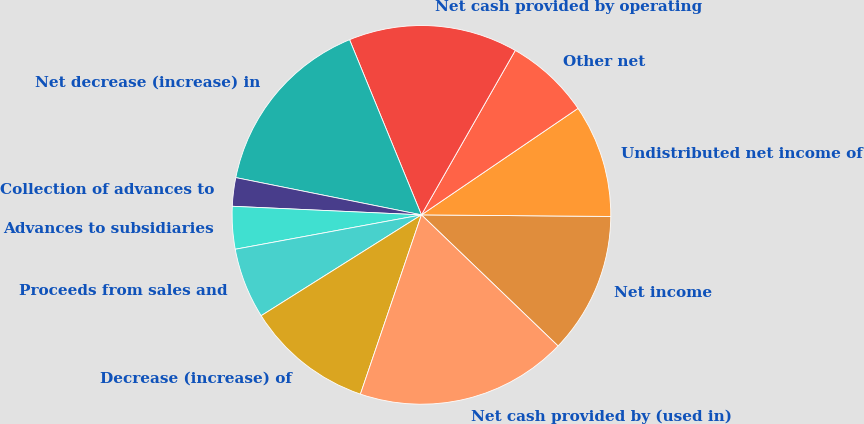<chart> <loc_0><loc_0><loc_500><loc_500><pie_chart><fcel>Net income<fcel>Undistributed net income of<fcel>Other net<fcel>Net cash provided by operating<fcel>Net decrease (increase) in<fcel>Collection of advances to<fcel>Advances to subsidiaries<fcel>Proceeds from sales and<fcel>Decrease (increase) of<fcel>Net cash provided by (used in)<nl><fcel>12.04%<fcel>9.64%<fcel>7.24%<fcel>14.45%<fcel>15.65%<fcel>2.43%<fcel>3.63%<fcel>6.03%<fcel>10.84%<fcel>18.05%<nl></chart> 